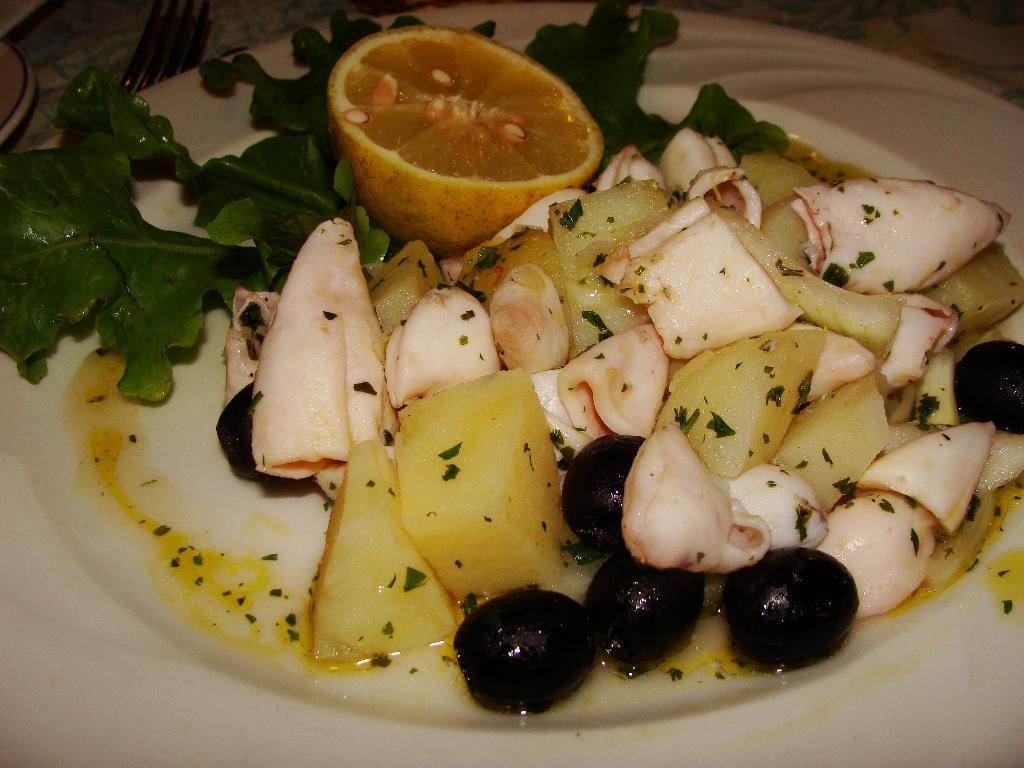Please provide a concise description of this image. In this image we can see some food on the white plate, one fork and two plates on the table. 